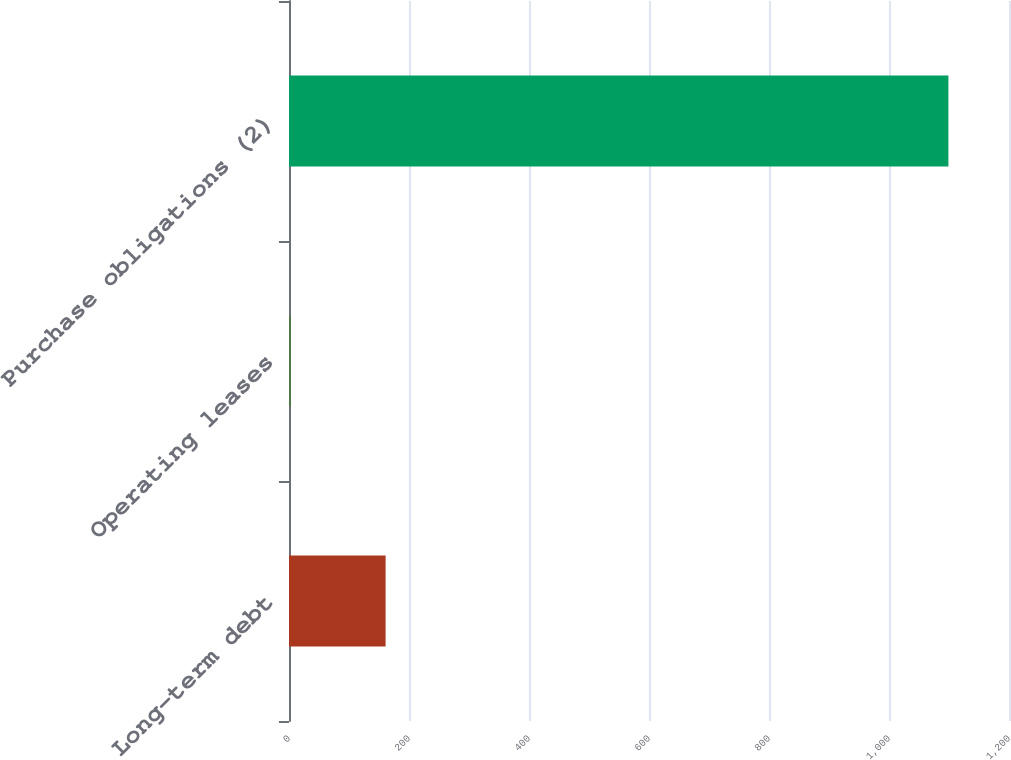Convert chart to OTSL. <chart><loc_0><loc_0><loc_500><loc_500><bar_chart><fcel>Long-term debt<fcel>Operating leases<fcel>Purchase obligations (2)<nl><fcel>161<fcel>3<fcel>1099<nl></chart> 